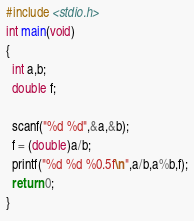Convert code to text. <code><loc_0><loc_0><loc_500><loc_500><_C_>#include <stdio.h>
int main(void)
{
  int a,b;
  double f;

  scanf("%d %d",&a,&b);
  f = (double)a/b;
  printf("%d %d %0.5f\n",a/b,a%b,f);
  return 0;
}</code> 